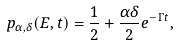<formula> <loc_0><loc_0><loc_500><loc_500>p _ { \alpha , \delta } ( E , t ) = \frac { 1 } { 2 } + \frac { \alpha \delta } { 2 } e ^ { - \Gamma t } ,</formula> 